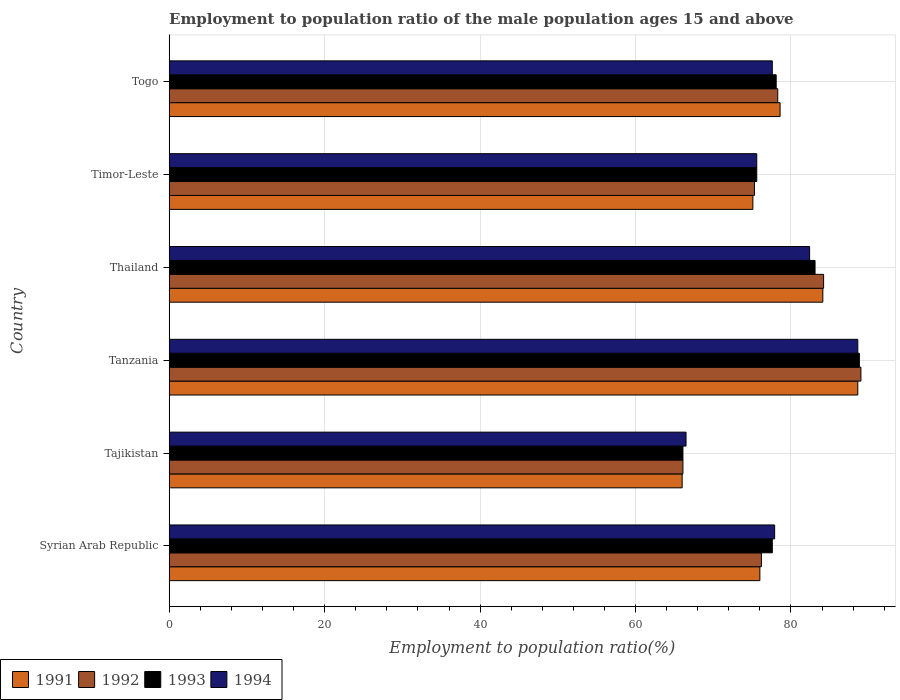How many groups of bars are there?
Give a very brief answer. 6. Are the number of bars per tick equal to the number of legend labels?
Offer a very short reply. Yes. How many bars are there on the 3rd tick from the top?
Offer a very short reply. 4. How many bars are there on the 2nd tick from the bottom?
Ensure brevity in your answer.  4. What is the label of the 1st group of bars from the top?
Make the answer very short. Togo. In how many cases, is the number of bars for a given country not equal to the number of legend labels?
Your response must be concise. 0. What is the employment to population ratio in 1993 in Tanzania?
Offer a very short reply. 88.8. Across all countries, what is the maximum employment to population ratio in 1993?
Offer a very short reply. 88.8. Across all countries, what is the minimum employment to population ratio in 1994?
Your answer should be compact. 66.5. In which country was the employment to population ratio in 1994 maximum?
Your response must be concise. Tanzania. In which country was the employment to population ratio in 1994 minimum?
Keep it short and to the point. Tajikistan. What is the total employment to population ratio in 1991 in the graph?
Keep it short and to the point. 468.4. What is the difference between the employment to population ratio in 1992 in Syrian Arab Republic and that in Timor-Leste?
Your answer should be very brief. 0.9. What is the average employment to population ratio in 1994 per country?
Your answer should be compact. 78.1. What is the difference between the employment to population ratio in 1994 and employment to population ratio in 1992 in Syrian Arab Republic?
Provide a succinct answer. 1.7. In how many countries, is the employment to population ratio in 1992 greater than 88 %?
Ensure brevity in your answer.  1. What is the ratio of the employment to population ratio in 1991 in Tajikistan to that in Togo?
Your answer should be very brief. 0.84. Is the employment to population ratio in 1993 in Syrian Arab Republic less than that in Tajikistan?
Provide a succinct answer. No. Is the difference between the employment to population ratio in 1994 in Syrian Arab Republic and Thailand greater than the difference between the employment to population ratio in 1992 in Syrian Arab Republic and Thailand?
Offer a very short reply. Yes. What is the difference between the highest and the lowest employment to population ratio in 1991?
Offer a terse response. 22.6. In how many countries, is the employment to population ratio in 1993 greater than the average employment to population ratio in 1993 taken over all countries?
Your answer should be compact. 2. What does the 2nd bar from the top in Syrian Arab Republic represents?
Offer a terse response. 1993. What does the 2nd bar from the bottom in Syrian Arab Republic represents?
Make the answer very short. 1992. Is it the case that in every country, the sum of the employment to population ratio in 1992 and employment to population ratio in 1993 is greater than the employment to population ratio in 1994?
Make the answer very short. Yes. Are all the bars in the graph horizontal?
Offer a terse response. Yes. What is the difference between two consecutive major ticks on the X-axis?
Your answer should be compact. 20. Does the graph contain any zero values?
Keep it short and to the point. No. Does the graph contain grids?
Provide a short and direct response. Yes. Where does the legend appear in the graph?
Ensure brevity in your answer.  Bottom left. How are the legend labels stacked?
Offer a terse response. Horizontal. What is the title of the graph?
Keep it short and to the point. Employment to population ratio of the male population ages 15 and above. What is the Employment to population ratio(%) of 1992 in Syrian Arab Republic?
Give a very brief answer. 76.2. What is the Employment to population ratio(%) in 1993 in Syrian Arab Republic?
Your answer should be very brief. 77.6. What is the Employment to population ratio(%) in 1994 in Syrian Arab Republic?
Make the answer very short. 77.9. What is the Employment to population ratio(%) in 1991 in Tajikistan?
Offer a very short reply. 66. What is the Employment to population ratio(%) of 1992 in Tajikistan?
Offer a very short reply. 66.1. What is the Employment to population ratio(%) of 1993 in Tajikistan?
Provide a succinct answer. 66.1. What is the Employment to population ratio(%) of 1994 in Tajikistan?
Make the answer very short. 66.5. What is the Employment to population ratio(%) in 1991 in Tanzania?
Your answer should be very brief. 88.6. What is the Employment to population ratio(%) in 1992 in Tanzania?
Your response must be concise. 89. What is the Employment to population ratio(%) in 1993 in Tanzania?
Ensure brevity in your answer.  88.8. What is the Employment to population ratio(%) in 1994 in Tanzania?
Offer a very short reply. 88.6. What is the Employment to population ratio(%) of 1991 in Thailand?
Provide a succinct answer. 84.1. What is the Employment to population ratio(%) in 1992 in Thailand?
Your response must be concise. 84.2. What is the Employment to population ratio(%) in 1993 in Thailand?
Keep it short and to the point. 83.1. What is the Employment to population ratio(%) in 1994 in Thailand?
Offer a very short reply. 82.4. What is the Employment to population ratio(%) in 1991 in Timor-Leste?
Make the answer very short. 75.1. What is the Employment to population ratio(%) of 1992 in Timor-Leste?
Provide a short and direct response. 75.3. What is the Employment to population ratio(%) of 1993 in Timor-Leste?
Provide a short and direct response. 75.6. What is the Employment to population ratio(%) of 1994 in Timor-Leste?
Your response must be concise. 75.6. What is the Employment to population ratio(%) of 1991 in Togo?
Provide a short and direct response. 78.6. What is the Employment to population ratio(%) in 1992 in Togo?
Your answer should be very brief. 78.3. What is the Employment to population ratio(%) in 1993 in Togo?
Keep it short and to the point. 78.1. What is the Employment to population ratio(%) in 1994 in Togo?
Offer a terse response. 77.6. Across all countries, what is the maximum Employment to population ratio(%) of 1991?
Ensure brevity in your answer.  88.6. Across all countries, what is the maximum Employment to population ratio(%) of 1992?
Offer a very short reply. 89. Across all countries, what is the maximum Employment to population ratio(%) in 1993?
Give a very brief answer. 88.8. Across all countries, what is the maximum Employment to population ratio(%) in 1994?
Your answer should be compact. 88.6. Across all countries, what is the minimum Employment to population ratio(%) of 1992?
Provide a succinct answer. 66.1. Across all countries, what is the minimum Employment to population ratio(%) of 1993?
Offer a terse response. 66.1. Across all countries, what is the minimum Employment to population ratio(%) in 1994?
Keep it short and to the point. 66.5. What is the total Employment to population ratio(%) in 1991 in the graph?
Provide a succinct answer. 468.4. What is the total Employment to population ratio(%) in 1992 in the graph?
Offer a terse response. 469.1. What is the total Employment to population ratio(%) in 1993 in the graph?
Your answer should be very brief. 469.3. What is the total Employment to population ratio(%) of 1994 in the graph?
Offer a very short reply. 468.6. What is the difference between the Employment to population ratio(%) of 1991 in Syrian Arab Republic and that in Tajikistan?
Provide a short and direct response. 10. What is the difference between the Employment to population ratio(%) in 1992 in Syrian Arab Republic and that in Tajikistan?
Keep it short and to the point. 10.1. What is the difference between the Employment to population ratio(%) in 1994 in Syrian Arab Republic and that in Tajikistan?
Provide a short and direct response. 11.4. What is the difference between the Employment to population ratio(%) of 1991 in Syrian Arab Republic and that in Thailand?
Provide a short and direct response. -8.1. What is the difference between the Employment to population ratio(%) of 1994 in Syrian Arab Republic and that in Thailand?
Offer a very short reply. -4.5. What is the difference between the Employment to population ratio(%) of 1993 in Syrian Arab Republic and that in Timor-Leste?
Ensure brevity in your answer.  2. What is the difference between the Employment to population ratio(%) in 1994 in Syrian Arab Republic and that in Timor-Leste?
Make the answer very short. 2.3. What is the difference between the Employment to population ratio(%) in 1991 in Syrian Arab Republic and that in Togo?
Make the answer very short. -2.6. What is the difference between the Employment to population ratio(%) of 1992 in Syrian Arab Republic and that in Togo?
Give a very brief answer. -2.1. What is the difference between the Employment to population ratio(%) in 1993 in Syrian Arab Republic and that in Togo?
Your response must be concise. -0.5. What is the difference between the Employment to population ratio(%) in 1994 in Syrian Arab Republic and that in Togo?
Offer a very short reply. 0.3. What is the difference between the Employment to population ratio(%) in 1991 in Tajikistan and that in Tanzania?
Offer a terse response. -22.6. What is the difference between the Employment to population ratio(%) of 1992 in Tajikistan and that in Tanzania?
Keep it short and to the point. -22.9. What is the difference between the Employment to population ratio(%) of 1993 in Tajikistan and that in Tanzania?
Offer a terse response. -22.7. What is the difference between the Employment to population ratio(%) of 1994 in Tajikistan and that in Tanzania?
Make the answer very short. -22.1. What is the difference between the Employment to population ratio(%) of 1991 in Tajikistan and that in Thailand?
Keep it short and to the point. -18.1. What is the difference between the Employment to population ratio(%) of 1992 in Tajikistan and that in Thailand?
Offer a very short reply. -18.1. What is the difference between the Employment to population ratio(%) of 1993 in Tajikistan and that in Thailand?
Offer a terse response. -17. What is the difference between the Employment to population ratio(%) of 1994 in Tajikistan and that in Thailand?
Keep it short and to the point. -15.9. What is the difference between the Employment to population ratio(%) in 1994 in Tajikistan and that in Timor-Leste?
Offer a very short reply. -9.1. What is the difference between the Employment to population ratio(%) of 1991 in Tajikistan and that in Togo?
Give a very brief answer. -12.6. What is the difference between the Employment to population ratio(%) in 1992 in Tajikistan and that in Togo?
Your answer should be compact. -12.2. What is the difference between the Employment to population ratio(%) of 1993 in Tajikistan and that in Togo?
Make the answer very short. -12. What is the difference between the Employment to population ratio(%) of 1993 in Tanzania and that in Thailand?
Give a very brief answer. 5.7. What is the difference between the Employment to population ratio(%) in 1994 in Tanzania and that in Thailand?
Give a very brief answer. 6.2. What is the difference between the Employment to population ratio(%) in 1993 in Tanzania and that in Timor-Leste?
Make the answer very short. 13.2. What is the difference between the Employment to population ratio(%) in 1994 in Tanzania and that in Timor-Leste?
Provide a succinct answer. 13. What is the difference between the Employment to population ratio(%) of 1991 in Tanzania and that in Togo?
Provide a short and direct response. 10. What is the difference between the Employment to population ratio(%) in 1991 in Thailand and that in Timor-Leste?
Your answer should be compact. 9. What is the difference between the Employment to population ratio(%) in 1993 in Thailand and that in Timor-Leste?
Ensure brevity in your answer.  7.5. What is the difference between the Employment to population ratio(%) in 1991 in Thailand and that in Togo?
Your answer should be compact. 5.5. What is the difference between the Employment to population ratio(%) in 1992 in Thailand and that in Togo?
Your answer should be very brief. 5.9. What is the difference between the Employment to population ratio(%) of 1994 in Thailand and that in Togo?
Provide a short and direct response. 4.8. What is the difference between the Employment to population ratio(%) of 1991 in Timor-Leste and that in Togo?
Offer a very short reply. -3.5. What is the difference between the Employment to population ratio(%) in 1992 in Timor-Leste and that in Togo?
Ensure brevity in your answer.  -3. What is the difference between the Employment to population ratio(%) of 1994 in Timor-Leste and that in Togo?
Keep it short and to the point. -2. What is the difference between the Employment to population ratio(%) in 1991 in Syrian Arab Republic and the Employment to population ratio(%) in 1994 in Tajikistan?
Offer a very short reply. 9.5. What is the difference between the Employment to population ratio(%) in 1992 in Syrian Arab Republic and the Employment to population ratio(%) in 1994 in Tajikistan?
Make the answer very short. 9.7. What is the difference between the Employment to population ratio(%) in 1991 in Syrian Arab Republic and the Employment to population ratio(%) in 1992 in Tanzania?
Provide a short and direct response. -13. What is the difference between the Employment to population ratio(%) of 1991 in Syrian Arab Republic and the Employment to population ratio(%) of 1993 in Tanzania?
Ensure brevity in your answer.  -12.8. What is the difference between the Employment to population ratio(%) of 1992 in Syrian Arab Republic and the Employment to population ratio(%) of 1994 in Tanzania?
Your answer should be compact. -12.4. What is the difference between the Employment to population ratio(%) of 1991 in Syrian Arab Republic and the Employment to population ratio(%) of 1993 in Thailand?
Offer a very short reply. -7.1. What is the difference between the Employment to population ratio(%) in 1991 in Syrian Arab Republic and the Employment to population ratio(%) in 1994 in Thailand?
Your answer should be compact. -6.4. What is the difference between the Employment to population ratio(%) of 1993 in Syrian Arab Republic and the Employment to population ratio(%) of 1994 in Thailand?
Offer a very short reply. -4.8. What is the difference between the Employment to population ratio(%) of 1991 in Syrian Arab Republic and the Employment to population ratio(%) of 1994 in Timor-Leste?
Your answer should be very brief. 0.4. What is the difference between the Employment to population ratio(%) in 1992 in Syrian Arab Republic and the Employment to population ratio(%) in 1993 in Timor-Leste?
Provide a short and direct response. 0.6. What is the difference between the Employment to population ratio(%) in 1992 in Syrian Arab Republic and the Employment to population ratio(%) in 1994 in Timor-Leste?
Offer a very short reply. 0.6. What is the difference between the Employment to population ratio(%) of 1993 in Syrian Arab Republic and the Employment to population ratio(%) of 1994 in Timor-Leste?
Your answer should be compact. 2. What is the difference between the Employment to population ratio(%) of 1991 in Syrian Arab Republic and the Employment to population ratio(%) of 1992 in Togo?
Provide a short and direct response. -2.3. What is the difference between the Employment to population ratio(%) in 1991 in Syrian Arab Republic and the Employment to population ratio(%) in 1993 in Togo?
Offer a very short reply. -2.1. What is the difference between the Employment to population ratio(%) in 1992 in Syrian Arab Republic and the Employment to population ratio(%) in 1993 in Togo?
Provide a succinct answer. -1.9. What is the difference between the Employment to population ratio(%) in 1992 in Syrian Arab Republic and the Employment to population ratio(%) in 1994 in Togo?
Your response must be concise. -1.4. What is the difference between the Employment to population ratio(%) of 1991 in Tajikistan and the Employment to population ratio(%) of 1992 in Tanzania?
Offer a very short reply. -23. What is the difference between the Employment to population ratio(%) of 1991 in Tajikistan and the Employment to population ratio(%) of 1993 in Tanzania?
Give a very brief answer. -22.8. What is the difference between the Employment to population ratio(%) in 1991 in Tajikistan and the Employment to population ratio(%) in 1994 in Tanzania?
Your response must be concise. -22.6. What is the difference between the Employment to population ratio(%) of 1992 in Tajikistan and the Employment to population ratio(%) of 1993 in Tanzania?
Your answer should be very brief. -22.7. What is the difference between the Employment to population ratio(%) in 1992 in Tajikistan and the Employment to population ratio(%) in 1994 in Tanzania?
Give a very brief answer. -22.5. What is the difference between the Employment to population ratio(%) in 1993 in Tajikistan and the Employment to population ratio(%) in 1994 in Tanzania?
Provide a short and direct response. -22.5. What is the difference between the Employment to population ratio(%) in 1991 in Tajikistan and the Employment to population ratio(%) in 1992 in Thailand?
Offer a very short reply. -18.2. What is the difference between the Employment to population ratio(%) of 1991 in Tajikistan and the Employment to population ratio(%) of 1993 in Thailand?
Ensure brevity in your answer.  -17.1. What is the difference between the Employment to population ratio(%) of 1991 in Tajikistan and the Employment to population ratio(%) of 1994 in Thailand?
Make the answer very short. -16.4. What is the difference between the Employment to population ratio(%) in 1992 in Tajikistan and the Employment to population ratio(%) in 1993 in Thailand?
Your answer should be very brief. -17. What is the difference between the Employment to population ratio(%) in 1992 in Tajikistan and the Employment to population ratio(%) in 1994 in Thailand?
Your answer should be compact. -16.3. What is the difference between the Employment to population ratio(%) in 1993 in Tajikistan and the Employment to population ratio(%) in 1994 in Thailand?
Your answer should be very brief. -16.3. What is the difference between the Employment to population ratio(%) in 1991 in Tajikistan and the Employment to population ratio(%) in 1994 in Timor-Leste?
Provide a succinct answer. -9.6. What is the difference between the Employment to population ratio(%) of 1992 in Tajikistan and the Employment to population ratio(%) of 1994 in Timor-Leste?
Your response must be concise. -9.5. What is the difference between the Employment to population ratio(%) of 1993 in Tajikistan and the Employment to population ratio(%) of 1994 in Timor-Leste?
Offer a terse response. -9.5. What is the difference between the Employment to population ratio(%) of 1992 in Tajikistan and the Employment to population ratio(%) of 1993 in Togo?
Provide a succinct answer. -12. What is the difference between the Employment to population ratio(%) of 1992 in Tanzania and the Employment to population ratio(%) of 1994 in Thailand?
Give a very brief answer. 6.6. What is the difference between the Employment to population ratio(%) in 1993 in Tanzania and the Employment to population ratio(%) in 1994 in Thailand?
Provide a short and direct response. 6.4. What is the difference between the Employment to population ratio(%) in 1991 in Tanzania and the Employment to population ratio(%) in 1993 in Timor-Leste?
Provide a succinct answer. 13. What is the difference between the Employment to population ratio(%) in 1991 in Tanzania and the Employment to population ratio(%) in 1994 in Timor-Leste?
Give a very brief answer. 13. What is the difference between the Employment to population ratio(%) in 1992 in Tanzania and the Employment to population ratio(%) in 1994 in Timor-Leste?
Keep it short and to the point. 13.4. What is the difference between the Employment to population ratio(%) in 1991 in Tanzania and the Employment to population ratio(%) in 1993 in Togo?
Your answer should be compact. 10.5. What is the difference between the Employment to population ratio(%) of 1991 in Tanzania and the Employment to population ratio(%) of 1994 in Togo?
Provide a succinct answer. 11. What is the difference between the Employment to population ratio(%) of 1992 in Tanzania and the Employment to population ratio(%) of 1993 in Togo?
Ensure brevity in your answer.  10.9. What is the difference between the Employment to population ratio(%) of 1992 in Tanzania and the Employment to population ratio(%) of 1994 in Togo?
Your response must be concise. 11.4. What is the difference between the Employment to population ratio(%) of 1991 in Thailand and the Employment to population ratio(%) of 1992 in Timor-Leste?
Ensure brevity in your answer.  8.8. What is the difference between the Employment to population ratio(%) in 1991 in Thailand and the Employment to population ratio(%) in 1993 in Timor-Leste?
Provide a succinct answer. 8.5. What is the difference between the Employment to population ratio(%) of 1992 in Thailand and the Employment to population ratio(%) of 1993 in Timor-Leste?
Ensure brevity in your answer.  8.6. What is the difference between the Employment to population ratio(%) of 1992 in Thailand and the Employment to population ratio(%) of 1994 in Timor-Leste?
Ensure brevity in your answer.  8.6. What is the difference between the Employment to population ratio(%) of 1992 in Thailand and the Employment to population ratio(%) of 1993 in Togo?
Make the answer very short. 6.1. What is the difference between the Employment to population ratio(%) in 1993 in Thailand and the Employment to population ratio(%) in 1994 in Togo?
Provide a succinct answer. 5.5. What is the difference between the Employment to population ratio(%) of 1991 in Timor-Leste and the Employment to population ratio(%) of 1993 in Togo?
Offer a terse response. -3. What is the difference between the Employment to population ratio(%) in 1991 in Timor-Leste and the Employment to population ratio(%) in 1994 in Togo?
Your answer should be compact. -2.5. What is the average Employment to population ratio(%) in 1991 per country?
Keep it short and to the point. 78.07. What is the average Employment to population ratio(%) of 1992 per country?
Make the answer very short. 78.18. What is the average Employment to population ratio(%) in 1993 per country?
Offer a terse response. 78.22. What is the average Employment to population ratio(%) in 1994 per country?
Offer a very short reply. 78.1. What is the difference between the Employment to population ratio(%) in 1991 and Employment to population ratio(%) in 1992 in Syrian Arab Republic?
Offer a terse response. -0.2. What is the difference between the Employment to population ratio(%) of 1991 and Employment to population ratio(%) of 1993 in Syrian Arab Republic?
Make the answer very short. -1.6. What is the difference between the Employment to population ratio(%) of 1991 and Employment to population ratio(%) of 1994 in Syrian Arab Republic?
Provide a short and direct response. -1.9. What is the difference between the Employment to population ratio(%) in 1992 and Employment to population ratio(%) in 1994 in Syrian Arab Republic?
Provide a short and direct response. -1.7. What is the difference between the Employment to population ratio(%) of 1993 and Employment to population ratio(%) of 1994 in Syrian Arab Republic?
Make the answer very short. -0.3. What is the difference between the Employment to population ratio(%) of 1991 and Employment to population ratio(%) of 1993 in Tajikistan?
Provide a succinct answer. -0.1. What is the difference between the Employment to population ratio(%) in 1991 and Employment to population ratio(%) in 1994 in Tajikistan?
Provide a succinct answer. -0.5. What is the difference between the Employment to population ratio(%) in 1993 and Employment to population ratio(%) in 1994 in Tajikistan?
Your answer should be very brief. -0.4. What is the difference between the Employment to population ratio(%) in 1991 and Employment to population ratio(%) in 1994 in Tanzania?
Provide a succinct answer. 0. What is the difference between the Employment to population ratio(%) in 1992 and Employment to population ratio(%) in 1993 in Tanzania?
Offer a terse response. 0.2. What is the difference between the Employment to population ratio(%) of 1992 and Employment to population ratio(%) of 1994 in Tanzania?
Keep it short and to the point. 0.4. What is the difference between the Employment to population ratio(%) in 1993 and Employment to population ratio(%) in 1994 in Tanzania?
Provide a succinct answer. 0.2. What is the difference between the Employment to population ratio(%) in 1991 and Employment to population ratio(%) in 1993 in Thailand?
Keep it short and to the point. 1. What is the difference between the Employment to population ratio(%) of 1992 and Employment to population ratio(%) of 1993 in Thailand?
Your response must be concise. 1.1. What is the difference between the Employment to population ratio(%) of 1993 and Employment to population ratio(%) of 1994 in Thailand?
Offer a terse response. 0.7. What is the difference between the Employment to population ratio(%) of 1991 and Employment to population ratio(%) of 1992 in Timor-Leste?
Keep it short and to the point. -0.2. What is the difference between the Employment to population ratio(%) of 1992 and Employment to population ratio(%) of 1994 in Timor-Leste?
Ensure brevity in your answer.  -0.3. What is the difference between the Employment to population ratio(%) of 1991 and Employment to population ratio(%) of 1993 in Togo?
Ensure brevity in your answer.  0.5. What is the difference between the Employment to population ratio(%) of 1991 and Employment to population ratio(%) of 1994 in Togo?
Provide a succinct answer. 1. What is the difference between the Employment to population ratio(%) of 1992 and Employment to population ratio(%) of 1994 in Togo?
Provide a succinct answer. 0.7. What is the difference between the Employment to population ratio(%) of 1993 and Employment to population ratio(%) of 1994 in Togo?
Your response must be concise. 0.5. What is the ratio of the Employment to population ratio(%) of 1991 in Syrian Arab Republic to that in Tajikistan?
Offer a very short reply. 1.15. What is the ratio of the Employment to population ratio(%) in 1992 in Syrian Arab Republic to that in Tajikistan?
Your answer should be compact. 1.15. What is the ratio of the Employment to population ratio(%) of 1993 in Syrian Arab Republic to that in Tajikistan?
Give a very brief answer. 1.17. What is the ratio of the Employment to population ratio(%) of 1994 in Syrian Arab Republic to that in Tajikistan?
Provide a short and direct response. 1.17. What is the ratio of the Employment to population ratio(%) of 1991 in Syrian Arab Republic to that in Tanzania?
Give a very brief answer. 0.86. What is the ratio of the Employment to population ratio(%) of 1992 in Syrian Arab Republic to that in Tanzania?
Provide a succinct answer. 0.86. What is the ratio of the Employment to population ratio(%) in 1993 in Syrian Arab Republic to that in Tanzania?
Give a very brief answer. 0.87. What is the ratio of the Employment to population ratio(%) of 1994 in Syrian Arab Republic to that in Tanzania?
Provide a short and direct response. 0.88. What is the ratio of the Employment to population ratio(%) in 1991 in Syrian Arab Republic to that in Thailand?
Provide a short and direct response. 0.9. What is the ratio of the Employment to population ratio(%) of 1992 in Syrian Arab Republic to that in Thailand?
Offer a terse response. 0.91. What is the ratio of the Employment to population ratio(%) in 1993 in Syrian Arab Republic to that in Thailand?
Give a very brief answer. 0.93. What is the ratio of the Employment to population ratio(%) of 1994 in Syrian Arab Republic to that in Thailand?
Offer a terse response. 0.95. What is the ratio of the Employment to population ratio(%) in 1991 in Syrian Arab Republic to that in Timor-Leste?
Make the answer very short. 1.01. What is the ratio of the Employment to population ratio(%) of 1992 in Syrian Arab Republic to that in Timor-Leste?
Give a very brief answer. 1.01. What is the ratio of the Employment to population ratio(%) of 1993 in Syrian Arab Republic to that in Timor-Leste?
Ensure brevity in your answer.  1.03. What is the ratio of the Employment to population ratio(%) of 1994 in Syrian Arab Republic to that in Timor-Leste?
Make the answer very short. 1.03. What is the ratio of the Employment to population ratio(%) in 1991 in Syrian Arab Republic to that in Togo?
Offer a very short reply. 0.97. What is the ratio of the Employment to population ratio(%) of 1992 in Syrian Arab Republic to that in Togo?
Keep it short and to the point. 0.97. What is the ratio of the Employment to population ratio(%) of 1993 in Syrian Arab Republic to that in Togo?
Keep it short and to the point. 0.99. What is the ratio of the Employment to population ratio(%) in 1991 in Tajikistan to that in Tanzania?
Offer a terse response. 0.74. What is the ratio of the Employment to population ratio(%) in 1992 in Tajikistan to that in Tanzania?
Offer a very short reply. 0.74. What is the ratio of the Employment to population ratio(%) in 1993 in Tajikistan to that in Tanzania?
Your answer should be compact. 0.74. What is the ratio of the Employment to population ratio(%) of 1994 in Tajikistan to that in Tanzania?
Your answer should be compact. 0.75. What is the ratio of the Employment to population ratio(%) in 1991 in Tajikistan to that in Thailand?
Provide a succinct answer. 0.78. What is the ratio of the Employment to population ratio(%) of 1992 in Tajikistan to that in Thailand?
Your answer should be very brief. 0.79. What is the ratio of the Employment to population ratio(%) of 1993 in Tajikistan to that in Thailand?
Your answer should be compact. 0.8. What is the ratio of the Employment to population ratio(%) of 1994 in Tajikistan to that in Thailand?
Offer a terse response. 0.81. What is the ratio of the Employment to population ratio(%) of 1991 in Tajikistan to that in Timor-Leste?
Make the answer very short. 0.88. What is the ratio of the Employment to population ratio(%) of 1992 in Tajikistan to that in Timor-Leste?
Provide a succinct answer. 0.88. What is the ratio of the Employment to population ratio(%) of 1993 in Tajikistan to that in Timor-Leste?
Make the answer very short. 0.87. What is the ratio of the Employment to population ratio(%) of 1994 in Tajikistan to that in Timor-Leste?
Offer a very short reply. 0.88. What is the ratio of the Employment to population ratio(%) in 1991 in Tajikistan to that in Togo?
Offer a very short reply. 0.84. What is the ratio of the Employment to population ratio(%) of 1992 in Tajikistan to that in Togo?
Offer a very short reply. 0.84. What is the ratio of the Employment to population ratio(%) in 1993 in Tajikistan to that in Togo?
Provide a succinct answer. 0.85. What is the ratio of the Employment to population ratio(%) in 1994 in Tajikistan to that in Togo?
Your response must be concise. 0.86. What is the ratio of the Employment to population ratio(%) of 1991 in Tanzania to that in Thailand?
Your answer should be compact. 1.05. What is the ratio of the Employment to population ratio(%) in 1992 in Tanzania to that in Thailand?
Ensure brevity in your answer.  1.06. What is the ratio of the Employment to population ratio(%) in 1993 in Tanzania to that in Thailand?
Your response must be concise. 1.07. What is the ratio of the Employment to population ratio(%) of 1994 in Tanzania to that in Thailand?
Provide a succinct answer. 1.08. What is the ratio of the Employment to population ratio(%) in 1991 in Tanzania to that in Timor-Leste?
Your answer should be compact. 1.18. What is the ratio of the Employment to population ratio(%) in 1992 in Tanzania to that in Timor-Leste?
Ensure brevity in your answer.  1.18. What is the ratio of the Employment to population ratio(%) in 1993 in Tanzania to that in Timor-Leste?
Offer a terse response. 1.17. What is the ratio of the Employment to population ratio(%) of 1994 in Tanzania to that in Timor-Leste?
Make the answer very short. 1.17. What is the ratio of the Employment to population ratio(%) in 1991 in Tanzania to that in Togo?
Keep it short and to the point. 1.13. What is the ratio of the Employment to population ratio(%) in 1992 in Tanzania to that in Togo?
Make the answer very short. 1.14. What is the ratio of the Employment to population ratio(%) of 1993 in Tanzania to that in Togo?
Your response must be concise. 1.14. What is the ratio of the Employment to population ratio(%) of 1994 in Tanzania to that in Togo?
Offer a very short reply. 1.14. What is the ratio of the Employment to population ratio(%) of 1991 in Thailand to that in Timor-Leste?
Offer a very short reply. 1.12. What is the ratio of the Employment to population ratio(%) in 1992 in Thailand to that in Timor-Leste?
Provide a succinct answer. 1.12. What is the ratio of the Employment to population ratio(%) of 1993 in Thailand to that in Timor-Leste?
Your answer should be compact. 1.1. What is the ratio of the Employment to population ratio(%) of 1994 in Thailand to that in Timor-Leste?
Provide a short and direct response. 1.09. What is the ratio of the Employment to population ratio(%) of 1991 in Thailand to that in Togo?
Provide a short and direct response. 1.07. What is the ratio of the Employment to population ratio(%) of 1992 in Thailand to that in Togo?
Your answer should be compact. 1.08. What is the ratio of the Employment to population ratio(%) of 1993 in Thailand to that in Togo?
Offer a terse response. 1.06. What is the ratio of the Employment to population ratio(%) in 1994 in Thailand to that in Togo?
Offer a very short reply. 1.06. What is the ratio of the Employment to population ratio(%) of 1991 in Timor-Leste to that in Togo?
Give a very brief answer. 0.96. What is the ratio of the Employment to population ratio(%) in 1992 in Timor-Leste to that in Togo?
Your answer should be compact. 0.96. What is the ratio of the Employment to population ratio(%) in 1993 in Timor-Leste to that in Togo?
Provide a short and direct response. 0.97. What is the ratio of the Employment to population ratio(%) of 1994 in Timor-Leste to that in Togo?
Provide a succinct answer. 0.97. What is the difference between the highest and the second highest Employment to population ratio(%) of 1992?
Offer a terse response. 4.8. What is the difference between the highest and the second highest Employment to population ratio(%) in 1994?
Provide a short and direct response. 6.2. What is the difference between the highest and the lowest Employment to population ratio(%) of 1991?
Your answer should be compact. 22.6. What is the difference between the highest and the lowest Employment to population ratio(%) of 1992?
Your answer should be very brief. 22.9. What is the difference between the highest and the lowest Employment to population ratio(%) of 1993?
Give a very brief answer. 22.7. What is the difference between the highest and the lowest Employment to population ratio(%) in 1994?
Provide a short and direct response. 22.1. 